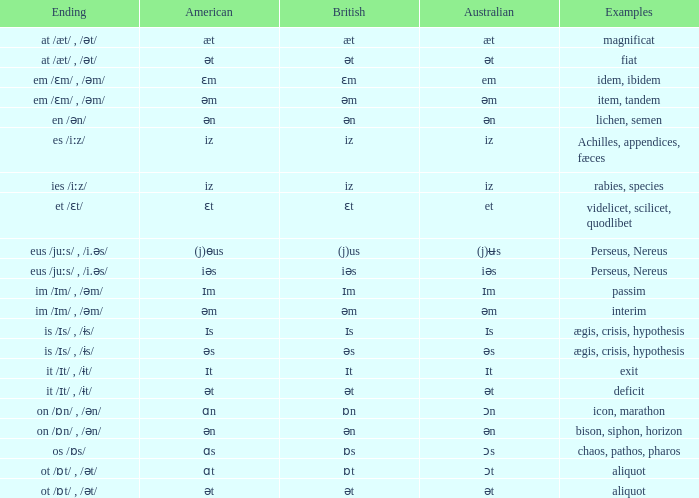Which American has British of ɛm? Ɛm. Can you give me this table as a dict? {'header': ['Ending', 'American', 'British', 'Australian', 'Examples'], 'rows': [['at /æt/ , /ət/', 'æt', 'æt', 'æt', 'magnificat'], ['at /æt/ , /ət/', 'ət', 'ət', 'ət', 'fiat'], ['em /ɛm/ , /əm/', 'ɛm', 'ɛm', 'em', 'idem, ibidem'], ['em /ɛm/ , /əm/', 'əm', 'əm', 'əm', 'item, tandem'], ['en /ən/', 'ən', 'ən', 'ən', 'lichen, semen'], ['es /iːz/', 'iz', 'iz', 'iz', 'Achilles, appendices, fæces'], ['ies /iːz/', 'iz', 'iz', 'iz', 'rabies, species'], ['et /ɛt/', 'ɛt', 'ɛt', 'et', 'videlicet, scilicet, quodlibet'], ['eus /juːs/ , /i.əs/', '(j)ɵus', '(j)us', '(j)ʉs', 'Perseus, Nereus'], ['eus /juːs/ , /i.əs/', 'iəs', 'iəs', 'iəs', 'Perseus, Nereus'], ['im /ɪm/ , /əm/', 'ɪm', 'ɪm', 'ɪm', 'passim'], ['im /ɪm/ , /əm/', 'əm', 'əm', 'əm', 'interim'], ['is /ɪs/ , /ɨs/', 'ɪs', 'ɪs', 'ɪs', 'ægis, crisis, hypothesis'], ['is /ɪs/ , /ɨs/', 'əs', 'əs', 'əs', 'ægis, crisis, hypothesis'], ['it /ɪt/ , /ɨt/', 'ɪt', 'ɪt', 'ɪt', 'exit'], ['it /ɪt/ , /ɨt/', 'ət', 'ət', 'ət', 'deficit'], ['on /ɒn/ , /ən/', 'ɑn', 'ɒn', 'ɔn', 'icon, marathon'], ['on /ɒn/ , /ən/', 'ən', 'ən', 'ən', 'bison, siphon, horizon'], ['os /ɒs/', 'ɑs', 'ɒs', 'ɔs', 'chaos, pathos, pharos'], ['ot /ɒt/ , /ət/', 'ɑt', 'ɒt', 'ɔt', 'aliquot'], ['ot /ɒt/ , /ət/', 'ət', 'ət', 'ət', 'aliquot']]} 